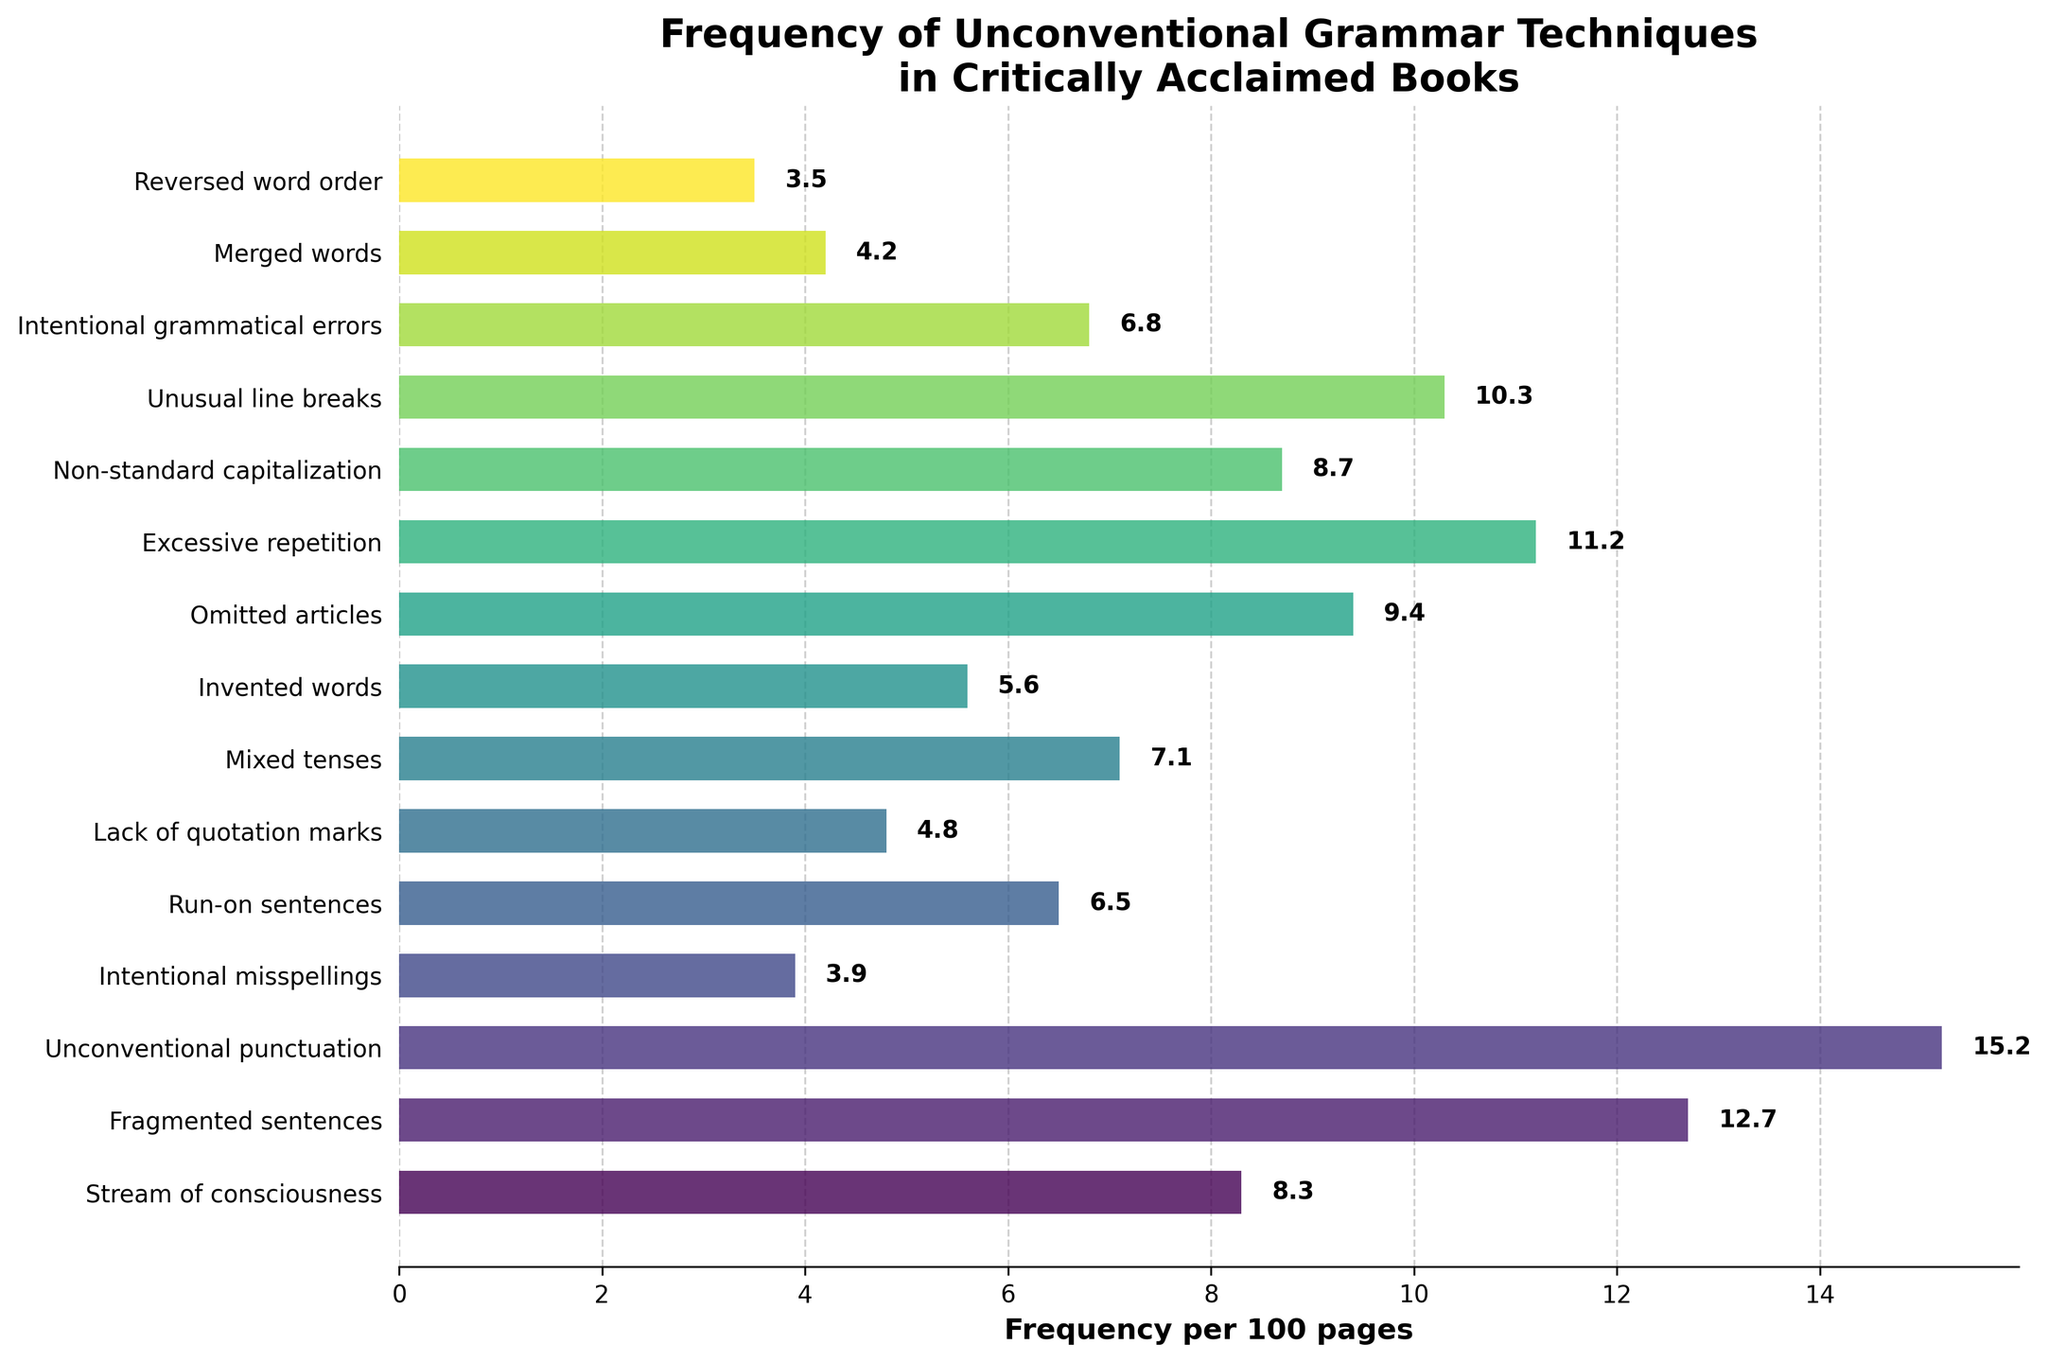What's the least frequent unconventional grammar technique used per 100 pages? The reversed word order has the lowest frequency, as it is visually the shortest bar in the chart.
Answer: Reversed word order Which unconventional grammar technique appears more frequently: mixed tenses or intentional grammatical errors? The bar length for intentional grammatical errors is longer than for mixed tenses, indicating it has a higher frequency.
Answer: Intentional grammatical errors What is the difference in frequency between fragmented sentences and intentional misspellings per 100 pages? The frequency of fragmented sentences is 12.7, and intentional misspellings is 3.9. Calculating the difference: 12.7 - 3.9 = 8.8.
Answer: 8.8 What is the total frequency of the three most frequent unconventional grammar techniques? The three most frequent techniques are unconventional punctuation (15.2), fragmented sentences (12.7), and excessive repetition (11.2). Summing them up: 15.2 + 12.7 + 11.2 = 39.1.
Answer: 39.1 How many unconventional grammar techniques have a frequency greater than 10 per 100 pages? By inspecting the chart, we see that unconventional punctuation, fragmented sentences, excessive repetition, and unusual line breaks have bars that extend beyond the 10-mark. This totals four techniques.
Answer: 4 What is the average frequency per 100 pages for all the unconventional grammar techniques? Add up all the frequencies: 8.3 + 12.7 + 15.2 + 3.9 + 6.5 + 4.8 + 7.1 + 5.6 + 9.4 + 11.2 + 8.7 + 10.3 + 6.8 + 4.2 + 3.5 = 118.2. There are 15 techniques, so the average is 118.2 / 15 ≈ 7.88.
Answer: 7.88 Which technique has a slightly longer bar than non-standard capitalization? Non-standard capitalization has a frequency of 8.7, and the technique with a slightly higher frequency (9.4) is omitted articles.
Answer: Omitted articles Among the techniques with less than 5 occurrences per 100 pages, which one is the least frequent? The techniques with less than 5 are intentional misspellings (3.9), merged words (4.2), and reversed word order (3.5). The least frequent among these is reversed word order.
Answer: Reversed word order What is the frequency difference between the most and least frequent unconventional grammar techniques? Most frequent is unconventional punctuation (15.2), and least frequent is reversed word order (3.5). The difference is 15.2 - 3.5 = 11.7.
Answer: 11.7 